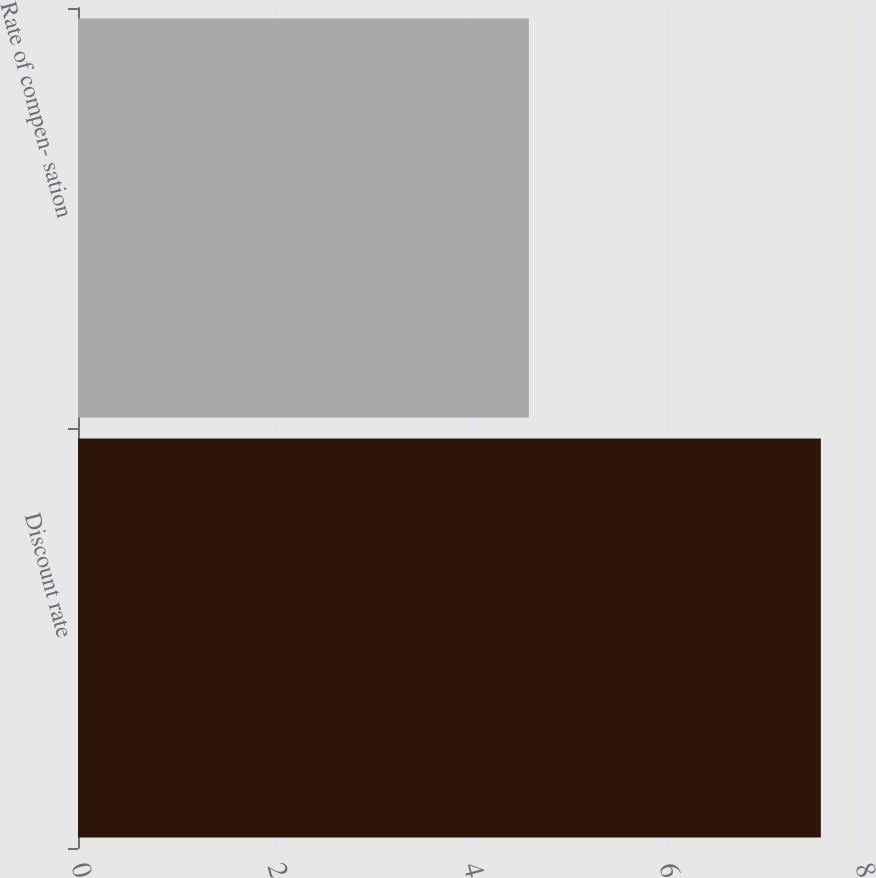<chart> <loc_0><loc_0><loc_500><loc_500><bar_chart><fcel>Discount rate<fcel>Rate of compen- sation<nl><fcel>7.58<fcel>4.6<nl></chart> 